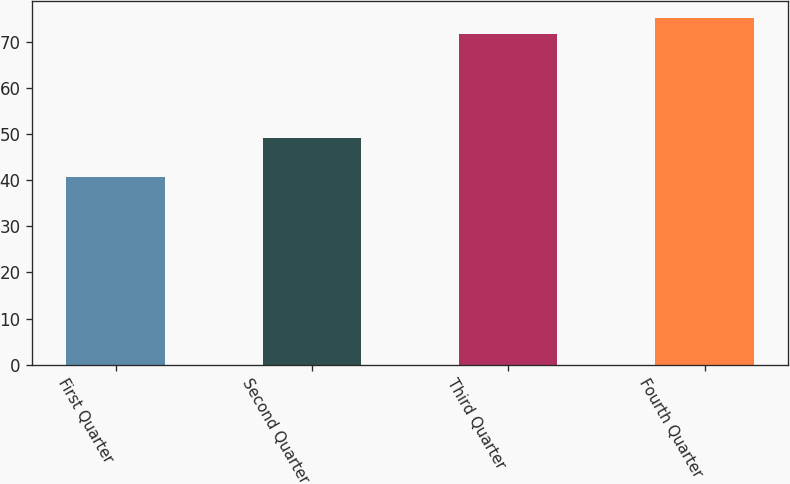<chart> <loc_0><loc_0><loc_500><loc_500><bar_chart><fcel>First Quarter<fcel>Second Quarter<fcel>Third Quarter<fcel>Fourth Quarter<nl><fcel>40.79<fcel>49.2<fcel>71.71<fcel>75.14<nl></chart> 